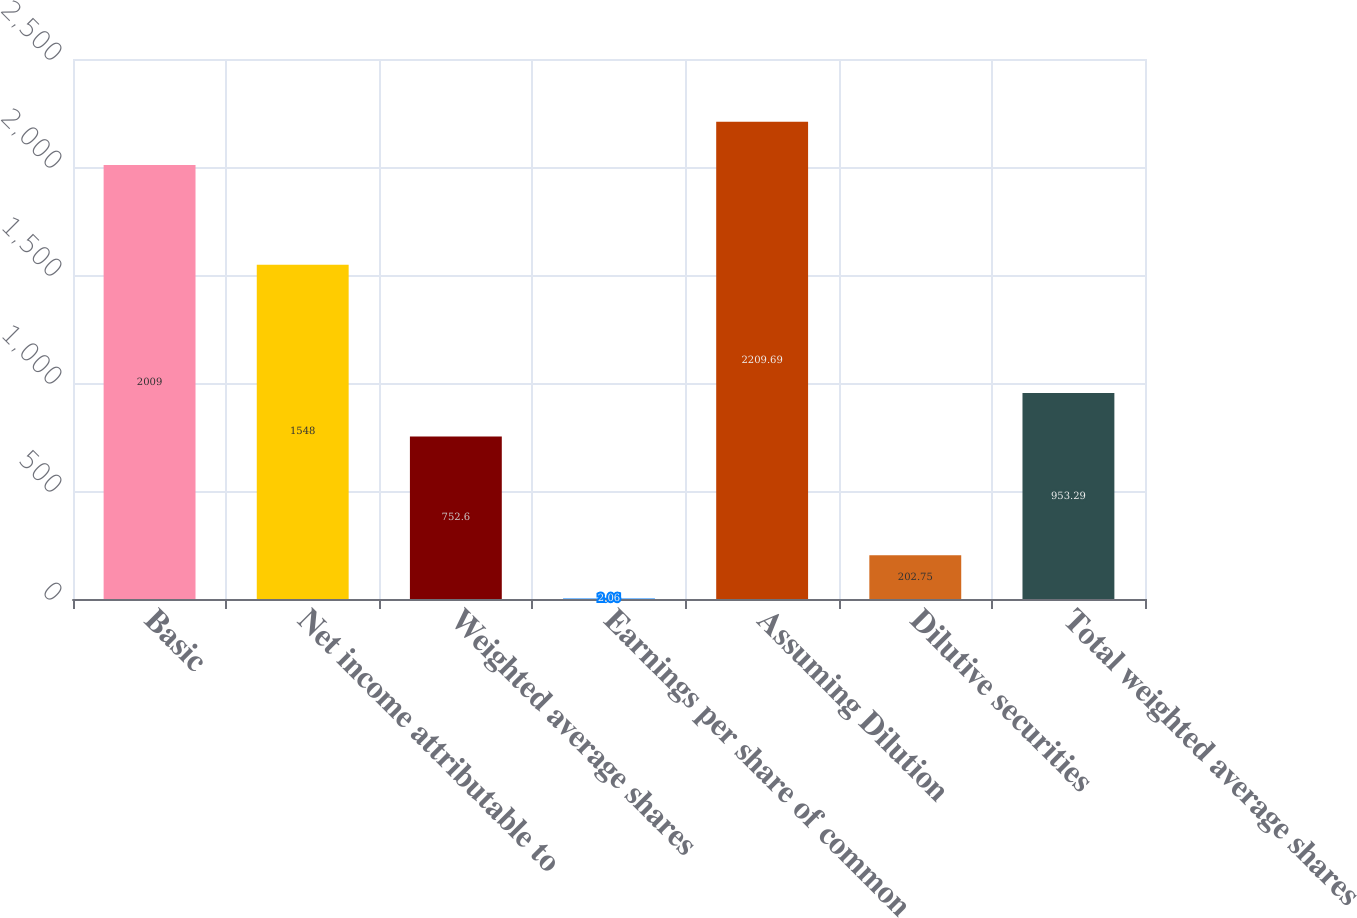<chart> <loc_0><loc_0><loc_500><loc_500><bar_chart><fcel>Basic<fcel>Net income attributable to<fcel>Weighted average shares<fcel>Earnings per share of common<fcel>Assuming Dilution<fcel>Dilutive securities<fcel>Total weighted average shares<nl><fcel>2009<fcel>1548<fcel>752.6<fcel>2.06<fcel>2209.69<fcel>202.75<fcel>953.29<nl></chart> 